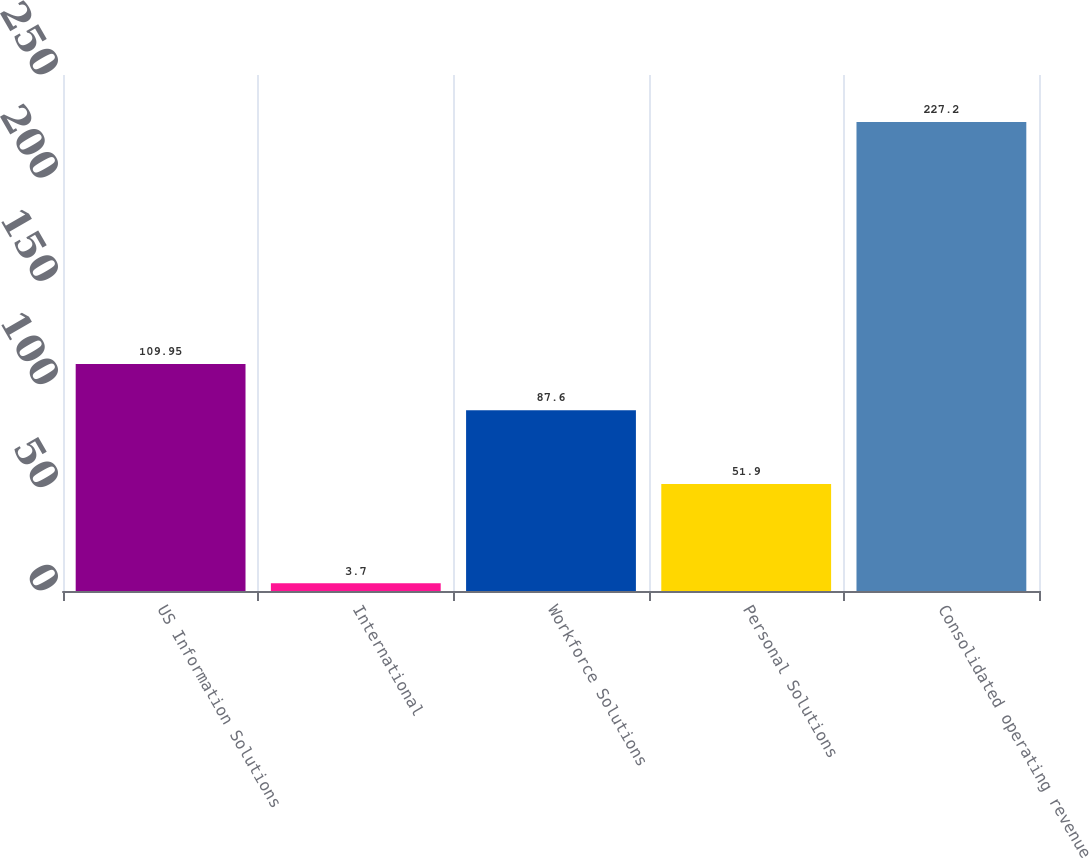Convert chart to OTSL. <chart><loc_0><loc_0><loc_500><loc_500><bar_chart><fcel>US Information Solutions<fcel>International<fcel>Workforce Solutions<fcel>Personal Solutions<fcel>Consolidated operating revenue<nl><fcel>109.95<fcel>3.7<fcel>87.6<fcel>51.9<fcel>227.2<nl></chart> 